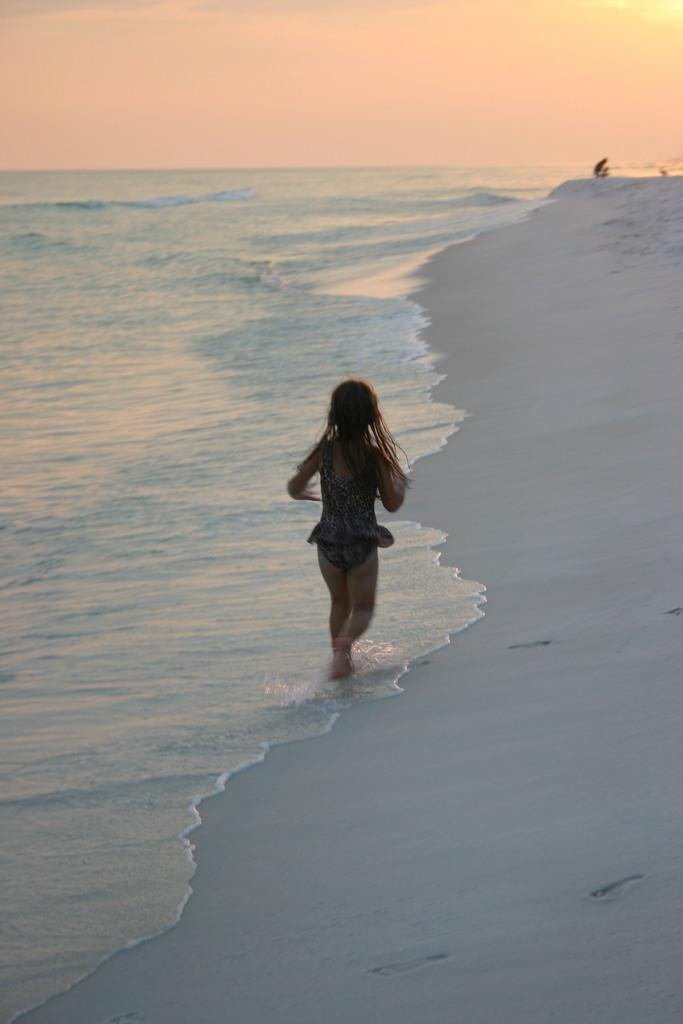Where was the image taken? The image was taken at the beach. Who is present in the image? There is a girl in the image. What can be seen in the background of the image? There is water, sand, and the sky visible in the image. What type of riddle is the girl trying to solve in the image? There is no riddle present in the image; it simply shows a girl at the beach. 